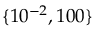Convert formula to latex. <formula><loc_0><loc_0><loc_500><loc_500>\{ 1 0 ^ { - 2 } , 1 0 0 \}</formula> 